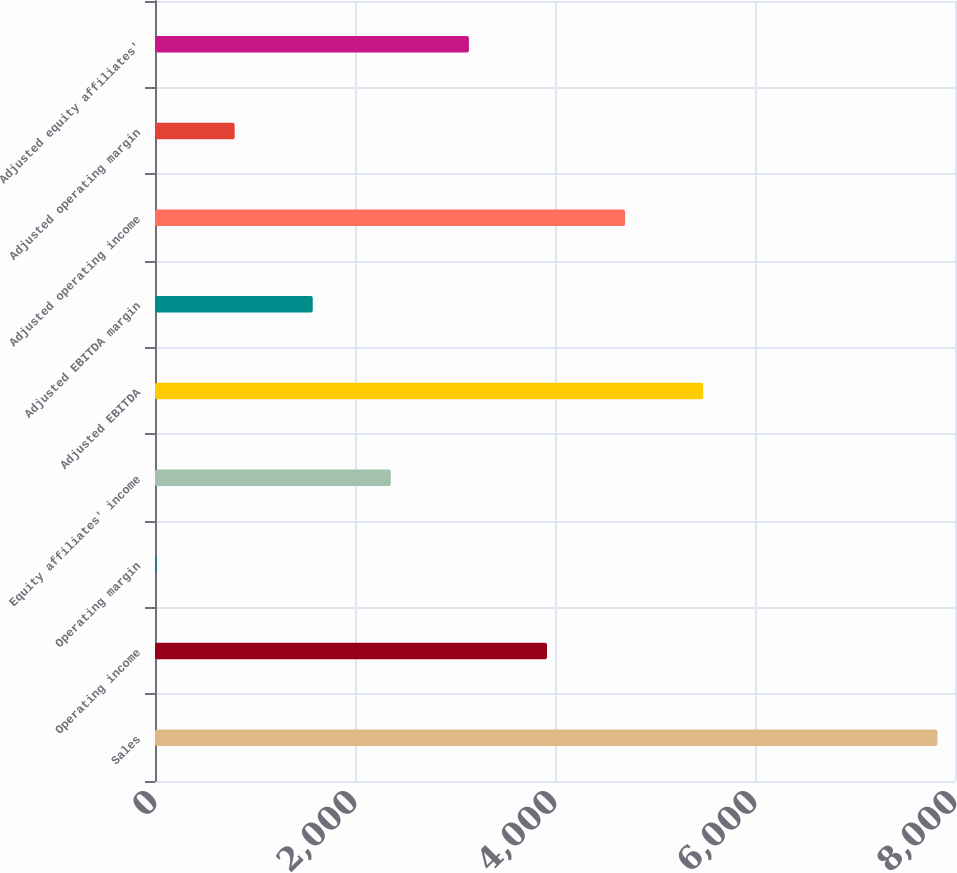<chart> <loc_0><loc_0><loc_500><loc_500><bar_chart><fcel>Sales<fcel>Operating income<fcel>Operating margin<fcel>Equity affiliates' income<fcel>Adjusted EBITDA<fcel>Adjusted EBITDA margin<fcel>Adjusted operating income<fcel>Adjusted operating margin<fcel>Adjusted equity affiliates'<nl><fcel>7824.3<fcel>3920.05<fcel>15.8<fcel>2358.35<fcel>5481.75<fcel>1577.5<fcel>4700.9<fcel>796.65<fcel>3139.2<nl></chart> 